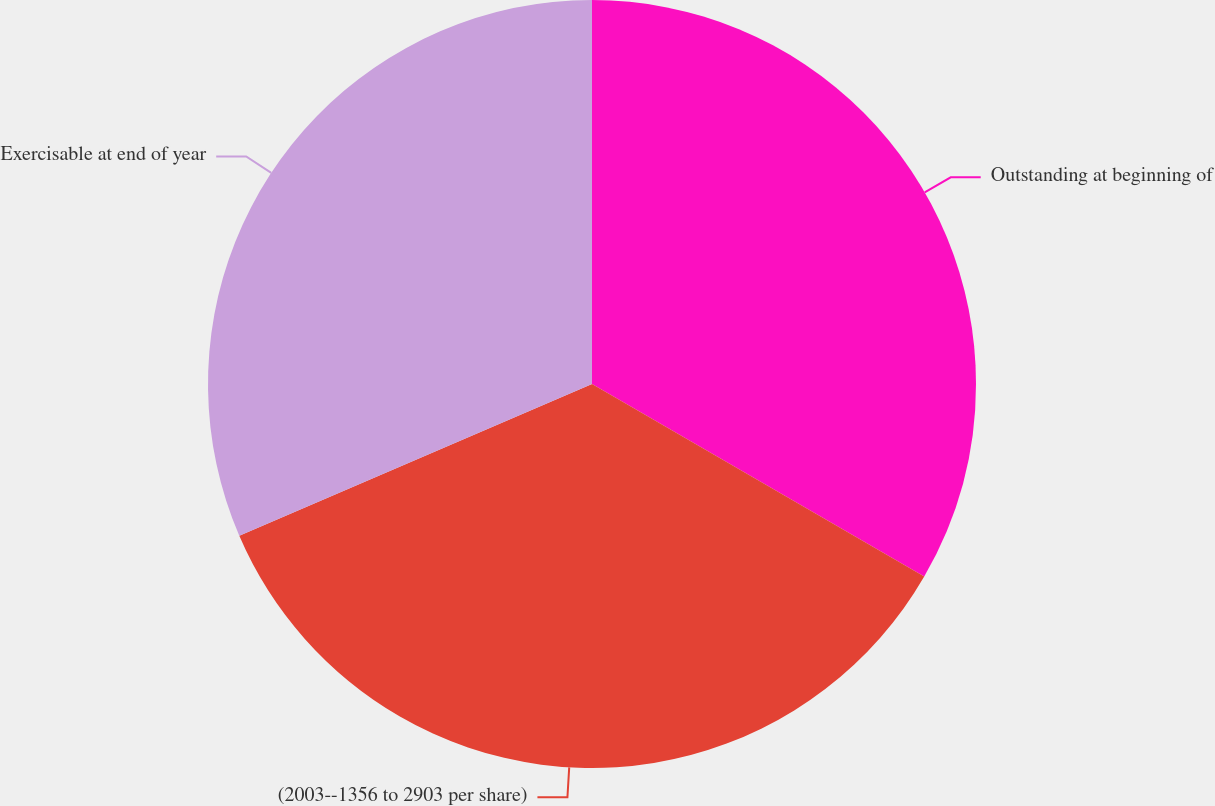Convert chart to OTSL. <chart><loc_0><loc_0><loc_500><loc_500><pie_chart><fcel>Outstanding at beginning of<fcel>(2003--1356 to 2903 per share)<fcel>Exercisable at end of year<nl><fcel>33.36%<fcel>35.17%<fcel>31.47%<nl></chart> 